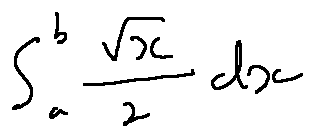<formula> <loc_0><loc_0><loc_500><loc_500>\int \lim i t s _ { a } ^ { b } \frac { \sqrt { x } } { 2 } d x</formula> 